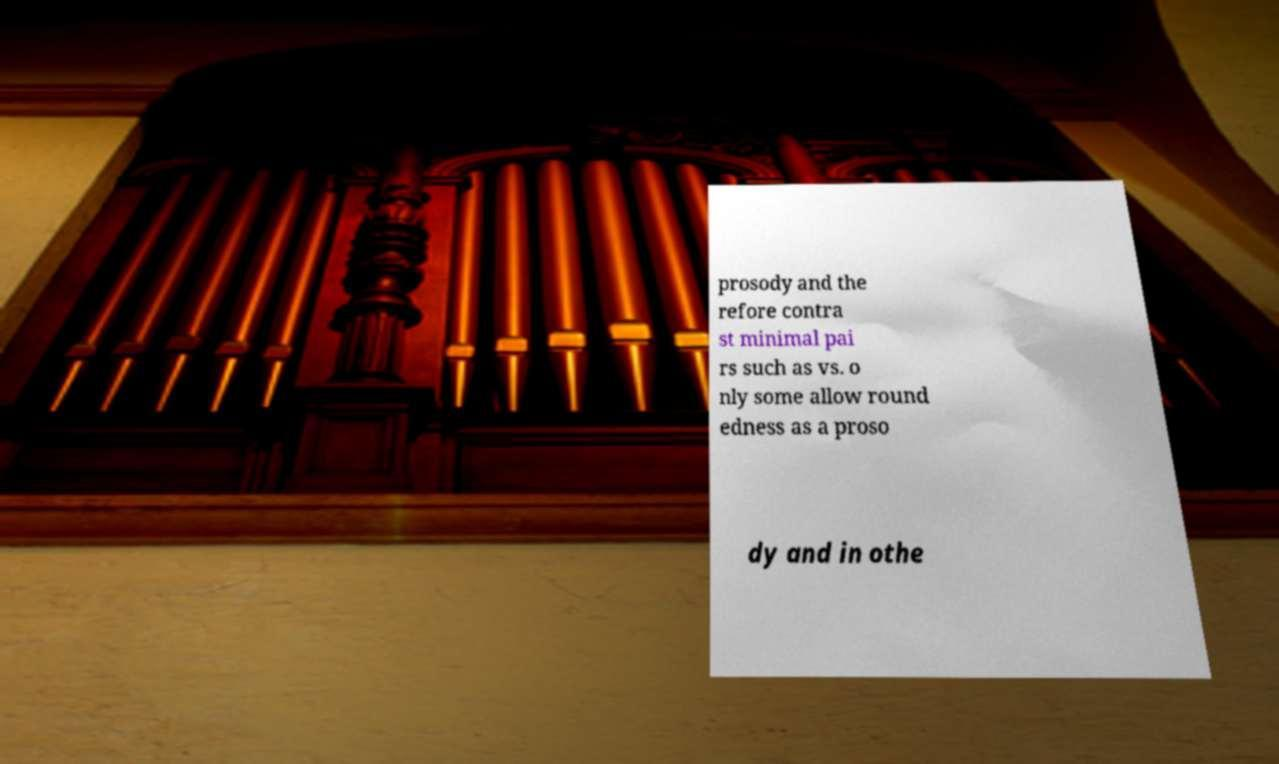For documentation purposes, I need the text within this image transcribed. Could you provide that? prosody and the refore contra st minimal pai rs such as vs. o nly some allow round edness as a proso dy and in othe 